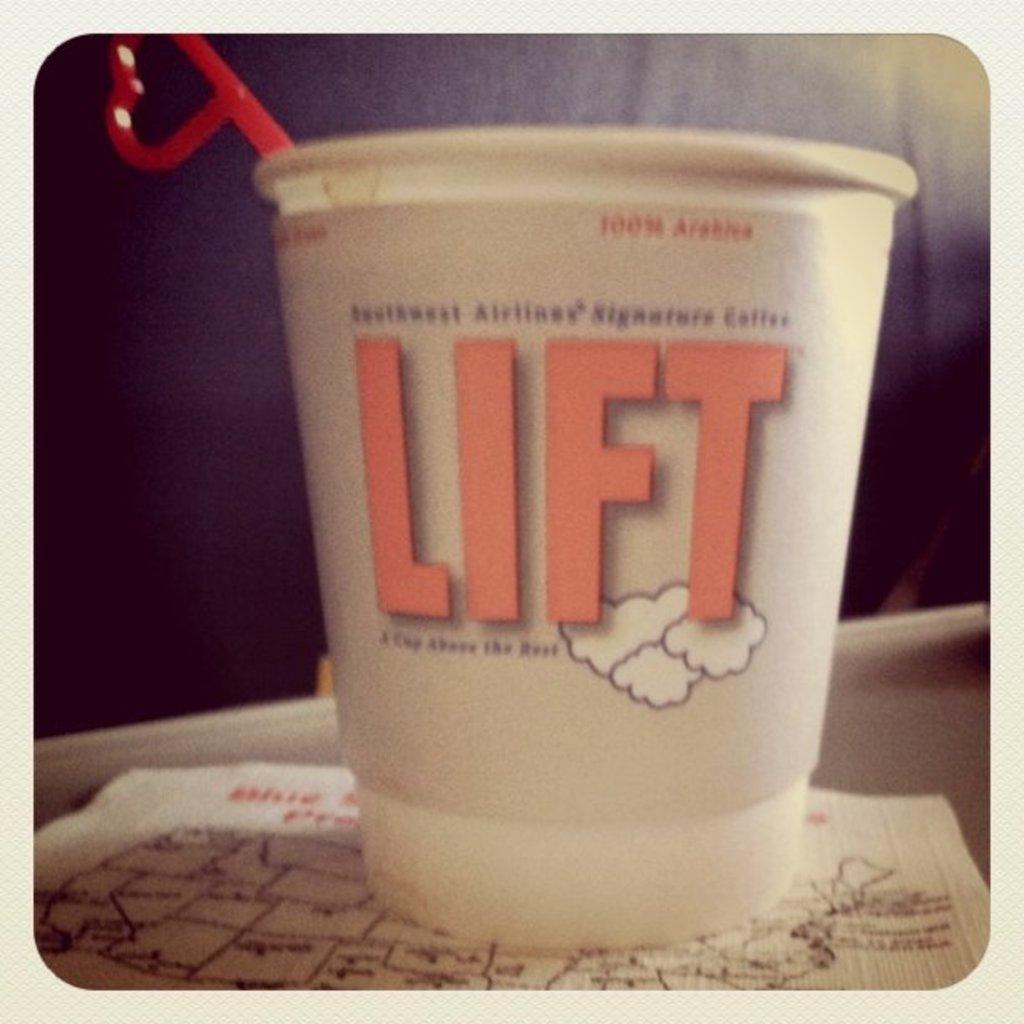Could you give a brief overview of what you see in this image? In this picture i could see small glass with a scoop in it placed on the paper on the counter top. 